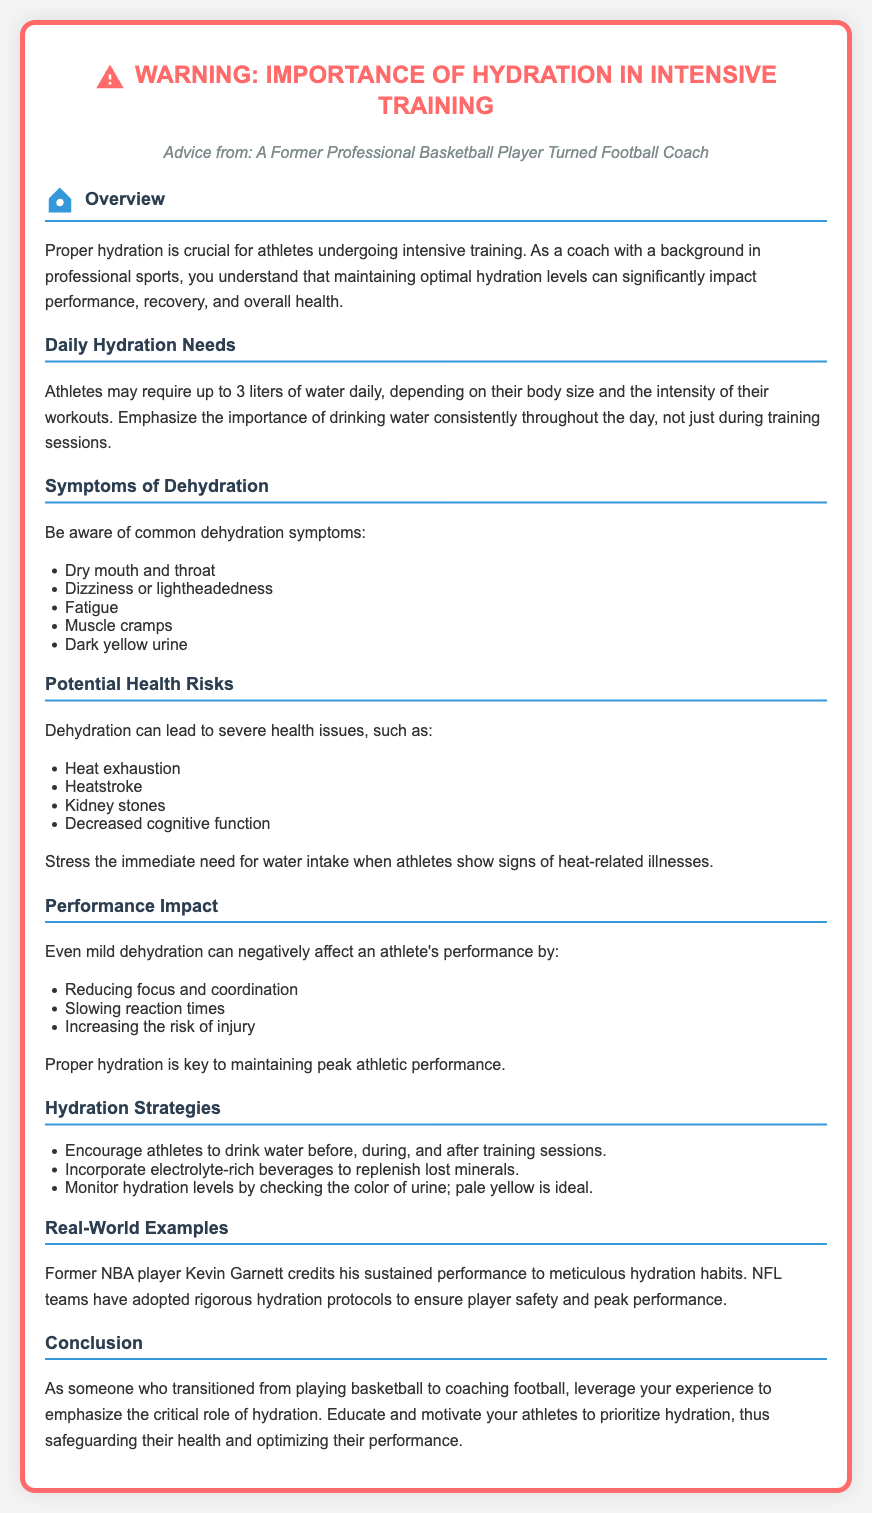What is the daily water requirement for athletes? The document states that athletes may require up to 3 liters of water daily.
Answer: 3 liters What are common symptoms of dehydration? The document lists several symptoms, including dry mouth and throat, dizziness, fatigue, muscle cramps, and dark yellow urine.
Answer: Dry mouth and throat What can dehydration lead to? The document mentions severe health issues such as heat exhaustion, heatstroke, and kidney stones.
Answer: Heat exhaustion How can dehydration affect athletic performance? The document explains that mild dehydration can reduce focus and coordination, slow reaction times, and increase the risk of injury.
Answer: Reducing focus and coordination What color of urine indicates ideal hydration levels? The document advises monitoring hydration levels by checking urine color; pale yellow is ideal.
Answer: Pale yellow Who is mentioned as an example of proper hydration habits? The document cites former NBA player Kevin Garnett as someone who credits his performance to hydration.
Answer: Kevin Garnett What is a recommended hydration strategy during training sessions? One of the strategies mentioned is to encourage athletes to drink water before, during, and after training sessions.
Answer: Drink water before, during, and after What is the consequence of ignoring signs of heat-related illnesses? The document stresses the immediate need for water intake when athletes show signs of heat-related illnesses, highlighting a significant consequence.
Answer: Severe health issues What is the document's purpose? The document serves as a warning about the importance of hydration in intensive training and its potential dangers.
Answer: Importance of hydration 